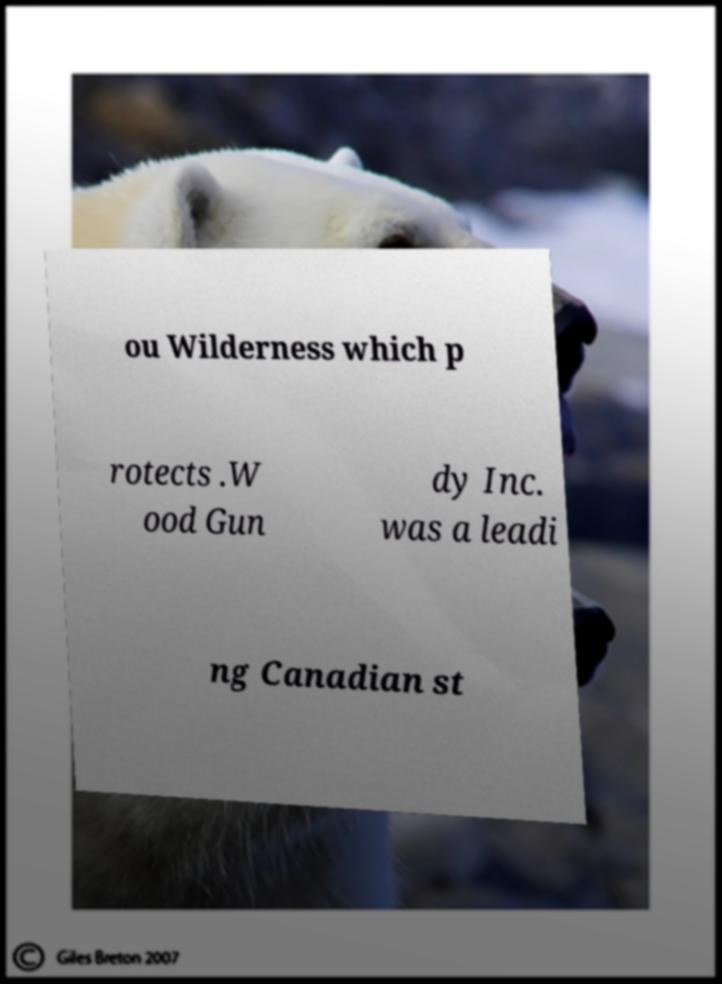Please read and relay the text visible in this image. What does it say? ou Wilderness which p rotects .W ood Gun dy Inc. was a leadi ng Canadian st 